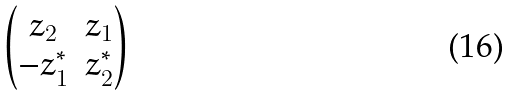Convert formula to latex. <formula><loc_0><loc_0><loc_500><loc_500>\begin{pmatrix} z _ { 2 } & z _ { 1 } \\ - z _ { 1 } ^ { * } & z _ { 2 } ^ { * } \end{pmatrix}</formula> 